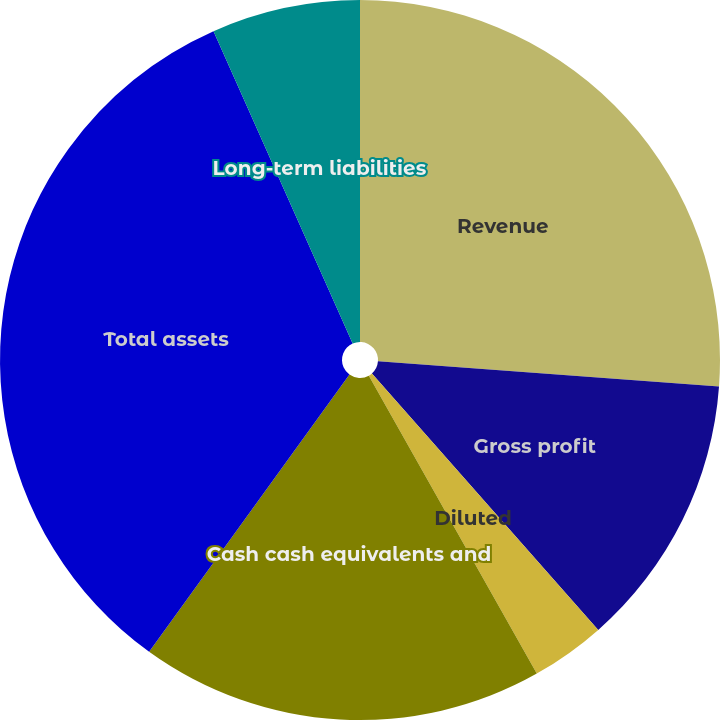Convert chart to OTSL. <chart><loc_0><loc_0><loc_500><loc_500><pie_chart><fcel>Revenue<fcel>Gross profit<fcel>Basic<fcel>Diluted<fcel>Cash cash equivalents and<fcel>Total assets<fcel>Long-term liabilities<nl><fcel>26.17%<fcel>12.32%<fcel>0.0%<fcel>3.34%<fcel>18.13%<fcel>33.37%<fcel>6.67%<nl></chart> 